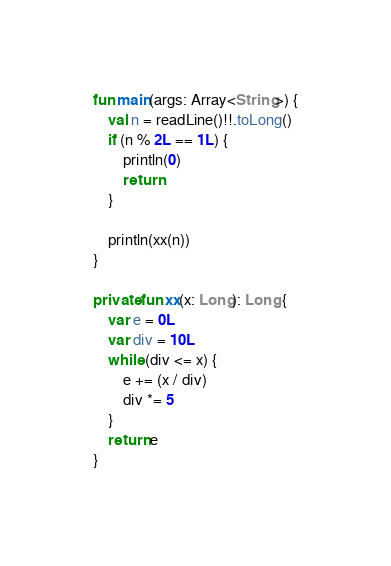Convert code to text. <code><loc_0><loc_0><loc_500><loc_500><_Kotlin_>
fun main(args: Array<String>) {
    val n = readLine()!!.toLong()
    if (n % 2L == 1L) {
        println(0)
        return
    }

    println(xx(n))
}

private fun xx(x: Long): Long {
    var e = 0L
    var div = 10L
    while (div <= x) {
        e += (x / div)
        div *= 5
    }
    return e
}
</code> 